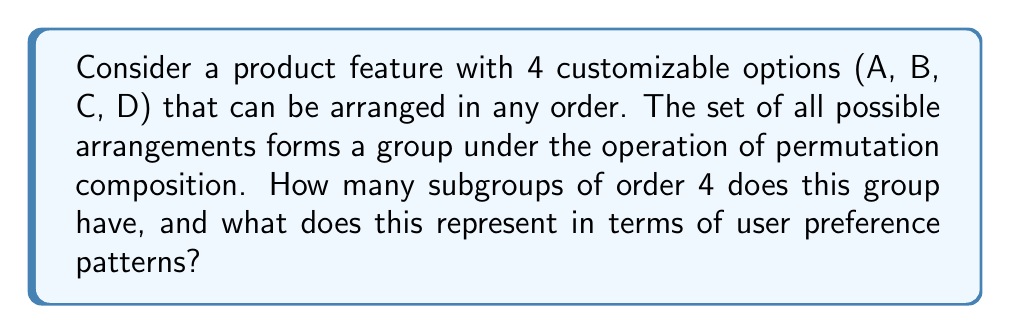Help me with this question. Let's approach this step-by-step:

1) First, we need to identify the group. The group of all permutations on 4 elements is the symmetric group $S_4$.

2) The order of $S_4$ is $4! = 24$.

3) We're looking for subgroups of order 4. In group theory, these are called Sylow 2-subgroups (as 4 = $2^2$).

4) To find the number of Sylow 2-subgroups, we can use Sylow's theorems. Let $n_2$ be the number of Sylow 2-subgroups. Then:

   $n_2 \equiv 1 \pmod{2}$
   $n_2$ divides 3 (as $24/(2^2) = 6/2 = 3$)

5) The only number that satisfies both conditions is 3.

6) We can verify this by identifying these subgroups:
   - $\{e, (AB)(CD), (AC)(BD), (AD)(BC)\}$
   - $\{e, (AB)(CD), (AC)(DC), (AD)(BC)\}$
   - $\{e, (AB)(CD), (AC)(BD), (AD)(CB)\}$

7) In terms of user preferences, each subgroup represents a pattern where users tend to swap pairs of options together. For example, in the first subgroup, if a user swaps A and B, they also tend to swap C and D.

8) The existence of 3 such subgroups suggests that there are three distinct pairing patterns that are mathematically significant in user behavior.
Answer: The group has 3 subgroups of order 4. This represents 3 distinct patterns of pairwise option swapping in user preferences. 